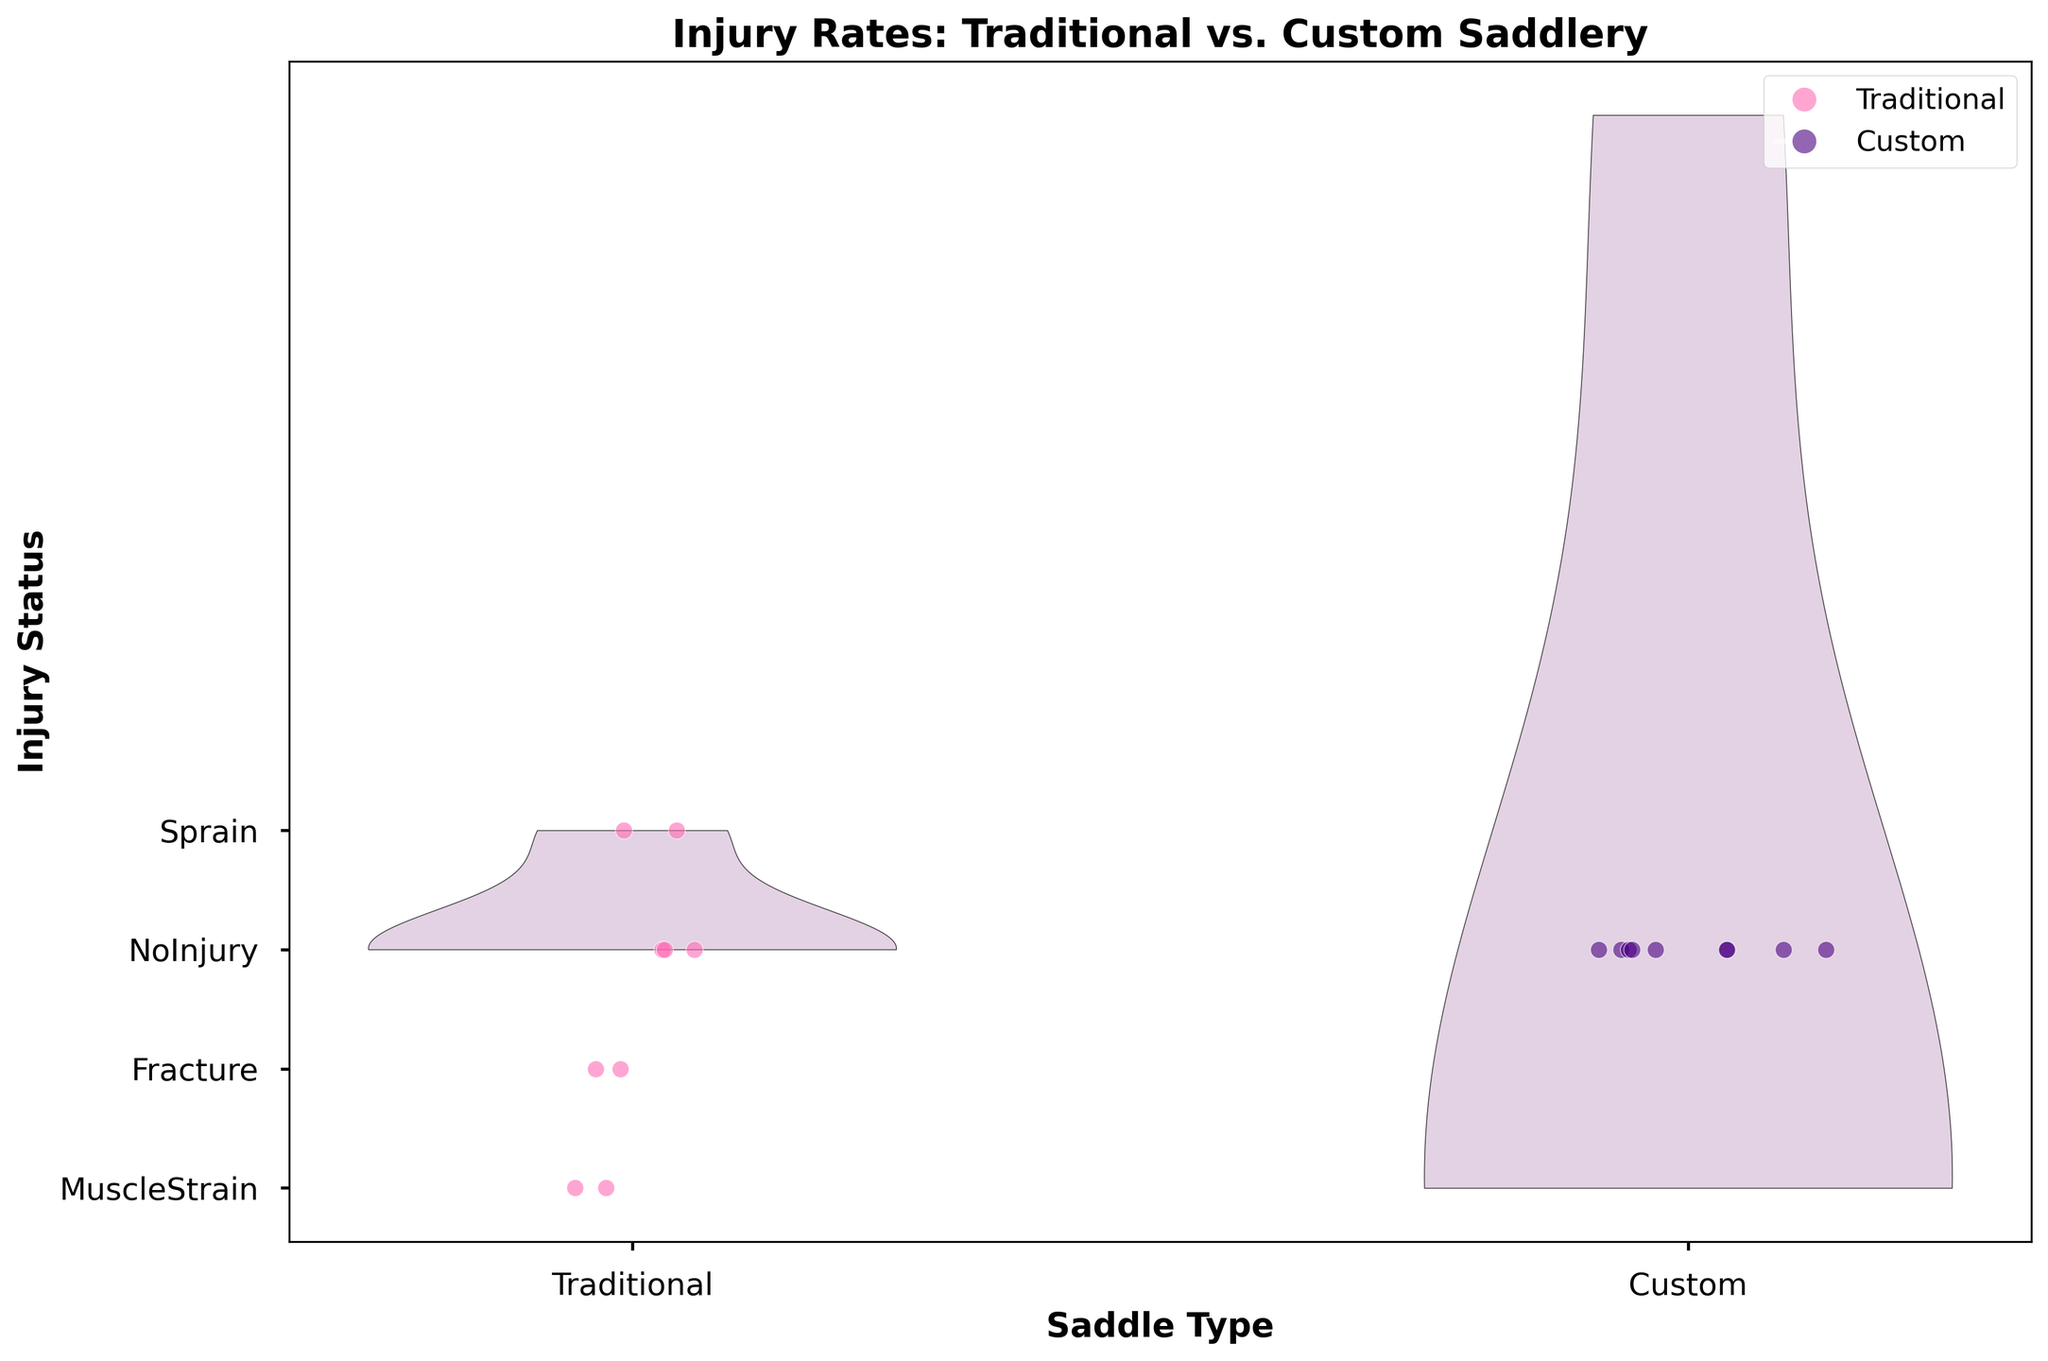What is the title of the figure? The title of the figure is displayed at the top and summarizes what the figure is about. In this case, it is written in bold and large font.
Answer: Injury Rates: Traditional vs. Custom Saddlery Which saddle type shows a higher variety of injury types? By comparing the y-axis labels, check which saddle type has the branches corresponding to more injury types. Traditional has five distinct types, while Custom has only one (NoInjury).
Answer: Traditional How many horses using Traditional saddles had a muscle strain? Refer to the y-axis marking muscle strain and see how many data points (markers) fall under Traditional saddle type (left side of the plot). There are two points.
Answer: 2 Which injury type is absent among horses using Custom saddles? Check the injury type labels on the y-axis and note which ones do not appear on the Custom side of the figure. All except NoInjury are absent on Custom Side.
Answer: Sprain, Fracture, MuscleStrain How many more horses using Traditional saddles had NoInjury compared to Custom saddles? From the Traditional side, count horses with NoInjury and do the same for the Custom side, then subtract to find the difference. There are 5 horses with NoInjury for Traditional and 7 for Custom, thus the difference is 7 - 5 = 2.
Answer: 2 more on Custom Comparing injury statuses, which saddle type appears to be better for preventing injuries? Observe the distribution of NoInjury data points for both saddle types. Custom Saddle has all NoInjury points while Traditional Saddle has a mix of injury types. This suggests Custom Saddles might be better for preventing injuries.
Answer: Custom Is there a difference in the spread of data points indicating injuries between the two saddle types? Look at the spread of data points along the y-axis for both Traditional and Custom saddles. Traditional shows a spread across multiple injury types, while Custom has all points clustered at NoInjury.
Answer: Yes, there is a difference In what manner is the data for individual horses represented in the plot? Observe the small scattered points in the figure; these represent individual data points for each horse's injury status. Each dot indicates an individual injury type for Traditional or Custom saddles.
Answer: Scatter plot Which color represents horses using Traditional saddles in the figure? Identify the color of scatter points on the Traditional side. They are colored in pink.
Answer: Pink Based on the figure, which injury type is most common among horses using Traditional saddles? Check the distribution of data points on the Traditional saddle side. The most common injury type will be represented by the highest number of points. NoInjury has the highest count on the Traditional side.
Answer: NoInjury 